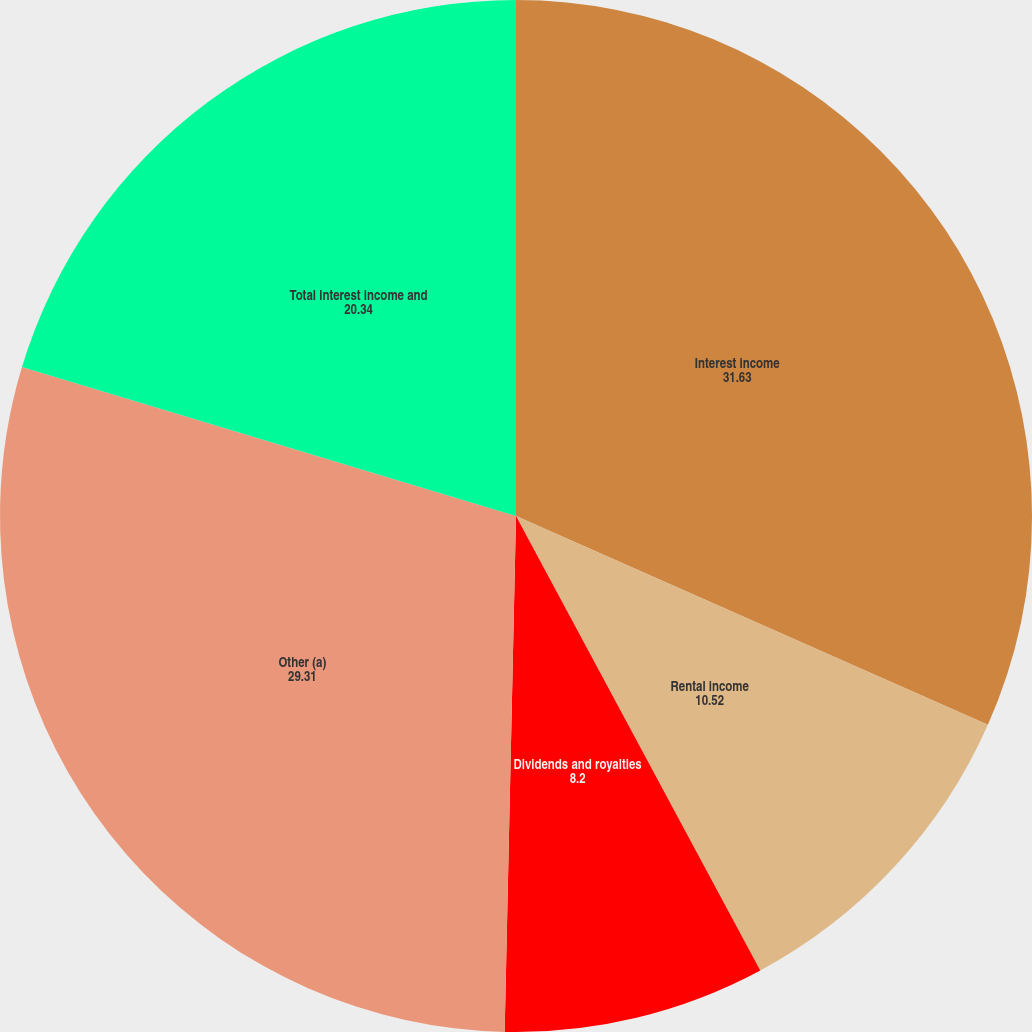<chart> <loc_0><loc_0><loc_500><loc_500><pie_chart><fcel>Interest income<fcel>Rental income<fcel>Dividends and royalties<fcel>Other (a)<fcel>Total interest income and<nl><fcel>31.63%<fcel>10.52%<fcel>8.2%<fcel>29.31%<fcel>20.34%<nl></chart> 